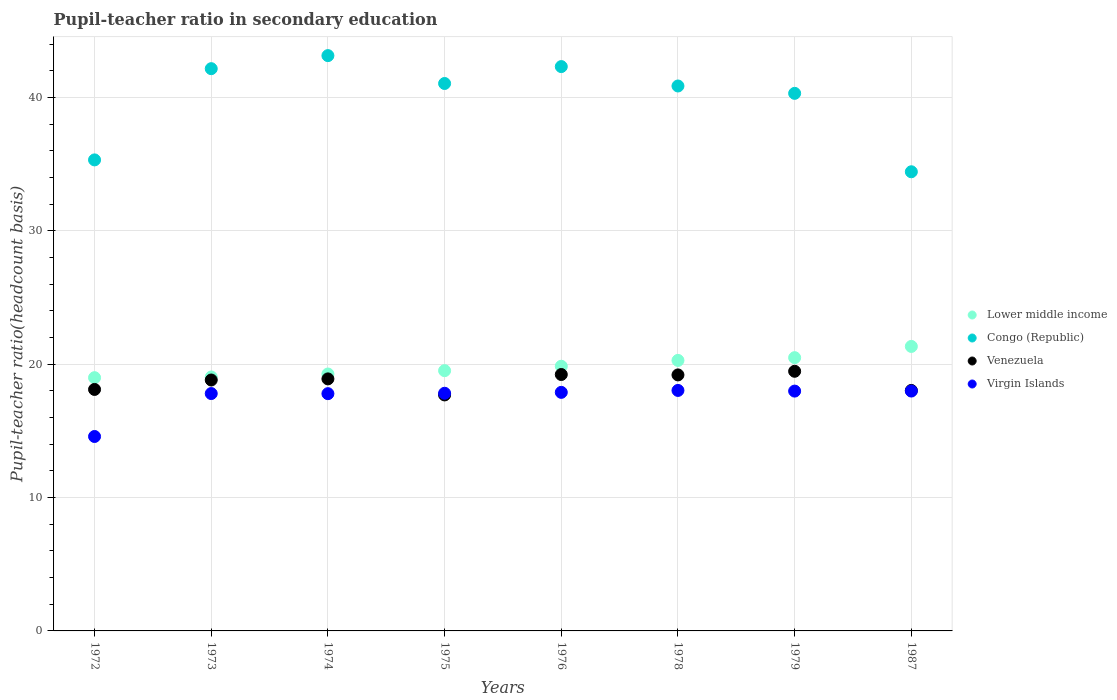How many different coloured dotlines are there?
Make the answer very short. 4. What is the pupil-teacher ratio in secondary education in Congo (Republic) in 1975?
Provide a succinct answer. 41.05. Across all years, what is the maximum pupil-teacher ratio in secondary education in Venezuela?
Your response must be concise. 19.47. Across all years, what is the minimum pupil-teacher ratio in secondary education in Virgin Islands?
Provide a succinct answer. 14.58. In which year was the pupil-teacher ratio in secondary education in Venezuela maximum?
Provide a succinct answer. 1979. What is the total pupil-teacher ratio in secondary education in Congo (Republic) in the graph?
Offer a terse response. 319.59. What is the difference between the pupil-teacher ratio in secondary education in Virgin Islands in 1974 and that in 1976?
Keep it short and to the point. -0.1. What is the difference between the pupil-teacher ratio in secondary education in Lower middle income in 1973 and the pupil-teacher ratio in secondary education in Venezuela in 1976?
Provide a succinct answer. -0.19. What is the average pupil-teacher ratio in secondary education in Lower middle income per year?
Offer a terse response. 19.85. In the year 1975, what is the difference between the pupil-teacher ratio in secondary education in Virgin Islands and pupil-teacher ratio in secondary education in Congo (Republic)?
Offer a very short reply. -23.23. In how many years, is the pupil-teacher ratio in secondary education in Congo (Republic) greater than 28?
Your answer should be compact. 8. What is the ratio of the pupil-teacher ratio in secondary education in Virgin Islands in 1978 to that in 1987?
Ensure brevity in your answer.  1. What is the difference between the highest and the second highest pupil-teacher ratio in secondary education in Venezuela?
Provide a short and direct response. 0.24. What is the difference between the highest and the lowest pupil-teacher ratio in secondary education in Lower middle income?
Ensure brevity in your answer.  2.34. In how many years, is the pupil-teacher ratio in secondary education in Venezuela greater than the average pupil-teacher ratio in secondary education in Venezuela taken over all years?
Your answer should be compact. 5. Is the sum of the pupil-teacher ratio in secondary education in Congo (Republic) in 1976 and 1978 greater than the maximum pupil-teacher ratio in secondary education in Virgin Islands across all years?
Offer a terse response. Yes. Is it the case that in every year, the sum of the pupil-teacher ratio in secondary education in Venezuela and pupil-teacher ratio in secondary education in Virgin Islands  is greater than the sum of pupil-teacher ratio in secondary education in Congo (Republic) and pupil-teacher ratio in secondary education in Lower middle income?
Offer a very short reply. No. Is it the case that in every year, the sum of the pupil-teacher ratio in secondary education in Venezuela and pupil-teacher ratio in secondary education in Lower middle income  is greater than the pupil-teacher ratio in secondary education in Virgin Islands?
Your answer should be very brief. Yes. Does the pupil-teacher ratio in secondary education in Lower middle income monotonically increase over the years?
Make the answer very short. Yes. How many years are there in the graph?
Give a very brief answer. 8. What is the difference between two consecutive major ticks on the Y-axis?
Offer a terse response. 10. Are the values on the major ticks of Y-axis written in scientific E-notation?
Provide a succinct answer. No. Does the graph contain any zero values?
Your answer should be very brief. No. How many legend labels are there?
Offer a terse response. 4. What is the title of the graph?
Offer a terse response. Pupil-teacher ratio in secondary education. Does "Faeroe Islands" appear as one of the legend labels in the graph?
Keep it short and to the point. No. What is the label or title of the Y-axis?
Make the answer very short. Pupil-teacher ratio(headcount basis). What is the Pupil-teacher ratio(headcount basis) in Lower middle income in 1972?
Ensure brevity in your answer.  18.99. What is the Pupil-teacher ratio(headcount basis) in Congo (Republic) in 1972?
Give a very brief answer. 35.32. What is the Pupil-teacher ratio(headcount basis) of Venezuela in 1972?
Provide a succinct answer. 18.11. What is the Pupil-teacher ratio(headcount basis) of Virgin Islands in 1972?
Offer a terse response. 14.58. What is the Pupil-teacher ratio(headcount basis) of Lower middle income in 1973?
Your answer should be very brief. 19.04. What is the Pupil-teacher ratio(headcount basis) in Congo (Republic) in 1973?
Offer a very short reply. 42.16. What is the Pupil-teacher ratio(headcount basis) in Venezuela in 1973?
Offer a terse response. 18.82. What is the Pupil-teacher ratio(headcount basis) of Virgin Islands in 1973?
Your answer should be compact. 17.8. What is the Pupil-teacher ratio(headcount basis) in Lower middle income in 1974?
Your answer should be compact. 19.26. What is the Pupil-teacher ratio(headcount basis) of Congo (Republic) in 1974?
Your response must be concise. 43.14. What is the Pupil-teacher ratio(headcount basis) of Venezuela in 1974?
Make the answer very short. 18.9. What is the Pupil-teacher ratio(headcount basis) in Virgin Islands in 1974?
Make the answer very short. 17.79. What is the Pupil-teacher ratio(headcount basis) of Lower middle income in 1975?
Provide a succinct answer. 19.52. What is the Pupil-teacher ratio(headcount basis) of Congo (Republic) in 1975?
Your answer should be very brief. 41.05. What is the Pupil-teacher ratio(headcount basis) in Venezuela in 1975?
Provide a short and direct response. 17.7. What is the Pupil-teacher ratio(headcount basis) of Virgin Islands in 1975?
Provide a short and direct response. 17.82. What is the Pupil-teacher ratio(headcount basis) of Lower middle income in 1976?
Provide a short and direct response. 19.85. What is the Pupil-teacher ratio(headcount basis) in Congo (Republic) in 1976?
Offer a very short reply. 42.32. What is the Pupil-teacher ratio(headcount basis) in Venezuela in 1976?
Keep it short and to the point. 19.23. What is the Pupil-teacher ratio(headcount basis) of Virgin Islands in 1976?
Your response must be concise. 17.89. What is the Pupil-teacher ratio(headcount basis) in Lower middle income in 1978?
Offer a very short reply. 20.28. What is the Pupil-teacher ratio(headcount basis) of Congo (Republic) in 1978?
Keep it short and to the point. 40.86. What is the Pupil-teacher ratio(headcount basis) of Venezuela in 1978?
Your answer should be compact. 19.2. What is the Pupil-teacher ratio(headcount basis) in Virgin Islands in 1978?
Your response must be concise. 18.03. What is the Pupil-teacher ratio(headcount basis) in Lower middle income in 1979?
Your answer should be compact. 20.49. What is the Pupil-teacher ratio(headcount basis) in Congo (Republic) in 1979?
Give a very brief answer. 40.31. What is the Pupil-teacher ratio(headcount basis) of Venezuela in 1979?
Your answer should be compact. 19.47. What is the Pupil-teacher ratio(headcount basis) in Virgin Islands in 1979?
Offer a very short reply. 17.98. What is the Pupil-teacher ratio(headcount basis) of Lower middle income in 1987?
Offer a terse response. 21.33. What is the Pupil-teacher ratio(headcount basis) of Congo (Republic) in 1987?
Provide a succinct answer. 34.43. What is the Pupil-teacher ratio(headcount basis) of Venezuela in 1987?
Offer a terse response. 18.03. What is the Pupil-teacher ratio(headcount basis) of Virgin Islands in 1987?
Provide a succinct answer. 17.99. Across all years, what is the maximum Pupil-teacher ratio(headcount basis) in Lower middle income?
Make the answer very short. 21.33. Across all years, what is the maximum Pupil-teacher ratio(headcount basis) in Congo (Republic)?
Keep it short and to the point. 43.14. Across all years, what is the maximum Pupil-teacher ratio(headcount basis) in Venezuela?
Offer a terse response. 19.47. Across all years, what is the maximum Pupil-teacher ratio(headcount basis) in Virgin Islands?
Make the answer very short. 18.03. Across all years, what is the minimum Pupil-teacher ratio(headcount basis) in Lower middle income?
Keep it short and to the point. 18.99. Across all years, what is the minimum Pupil-teacher ratio(headcount basis) in Congo (Republic)?
Keep it short and to the point. 34.43. Across all years, what is the minimum Pupil-teacher ratio(headcount basis) in Venezuela?
Make the answer very short. 17.7. Across all years, what is the minimum Pupil-teacher ratio(headcount basis) of Virgin Islands?
Keep it short and to the point. 14.58. What is the total Pupil-teacher ratio(headcount basis) of Lower middle income in the graph?
Offer a terse response. 158.76. What is the total Pupil-teacher ratio(headcount basis) of Congo (Republic) in the graph?
Give a very brief answer. 319.59. What is the total Pupil-teacher ratio(headcount basis) of Venezuela in the graph?
Offer a terse response. 149.44. What is the total Pupil-teacher ratio(headcount basis) in Virgin Islands in the graph?
Provide a short and direct response. 139.88. What is the difference between the Pupil-teacher ratio(headcount basis) in Lower middle income in 1972 and that in 1973?
Your answer should be very brief. -0.05. What is the difference between the Pupil-teacher ratio(headcount basis) of Congo (Republic) in 1972 and that in 1973?
Your answer should be very brief. -6.84. What is the difference between the Pupil-teacher ratio(headcount basis) in Venezuela in 1972 and that in 1973?
Ensure brevity in your answer.  -0.71. What is the difference between the Pupil-teacher ratio(headcount basis) of Virgin Islands in 1972 and that in 1973?
Your answer should be very brief. -3.22. What is the difference between the Pupil-teacher ratio(headcount basis) of Lower middle income in 1972 and that in 1974?
Offer a very short reply. -0.27. What is the difference between the Pupil-teacher ratio(headcount basis) in Congo (Republic) in 1972 and that in 1974?
Offer a very short reply. -7.82. What is the difference between the Pupil-teacher ratio(headcount basis) of Venezuela in 1972 and that in 1974?
Your response must be concise. -0.79. What is the difference between the Pupil-teacher ratio(headcount basis) of Virgin Islands in 1972 and that in 1974?
Offer a very short reply. -3.21. What is the difference between the Pupil-teacher ratio(headcount basis) of Lower middle income in 1972 and that in 1975?
Offer a terse response. -0.53. What is the difference between the Pupil-teacher ratio(headcount basis) of Congo (Republic) in 1972 and that in 1975?
Your answer should be very brief. -5.73. What is the difference between the Pupil-teacher ratio(headcount basis) in Venezuela in 1972 and that in 1975?
Your answer should be very brief. 0.41. What is the difference between the Pupil-teacher ratio(headcount basis) of Virgin Islands in 1972 and that in 1975?
Your answer should be very brief. -3.24. What is the difference between the Pupil-teacher ratio(headcount basis) of Lower middle income in 1972 and that in 1976?
Give a very brief answer. -0.86. What is the difference between the Pupil-teacher ratio(headcount basis) of Congo (Republic) in 1972 and that in 1976?
Your answer should be compact. -7. What is the difference between the Pupil-teacher ratio(headcount basis) in Venezuela in 1972 and that in 1976?
Your answer should be very brief. -1.12. What is the difference between the Pupil-teacher ratio(headcount basis) of Virgin Islands in 1972 and that in 1976?
Your response must be concise. -3.31. What is the difference between the Pupil-teacher ratio(headcount basis) of Lower middle income in 1972 and that in 1978?
Provide a short and direct response. -1.29. What is the difference between the Pupil-teacher ratio(headcount basis) in Congo (Republic) in 1972 and that in 1978?
Make the answer very short. -5.54. What is the difference between the Pupil-teacher ratio(headcount basis) of Venezuela in 1972 and that in 1978?
Your response must be concise. -1.09. What is the difference between the Pupil-teacher ratio(headcount basis) of Virgin Islands in 1972 and that in 1978?
Your answer should be compact. -3.45. What is the difference between the Pupil-teacher ratio(headcount basis) of Lower middle income in 1972 and that in 1979?
Your answer should be very brief. -1.5. What is the difference between the Pupil-teacher ratio(headcount basis) in Congo (Republic) in 1972 and that in 1979?
Your answer should be compact. -4.99. What is the difference between the Pupil-teacher ratio(headcount basis) in Venezuela in 1972 and that in 1979?
Keep it short and to the point. -1.36. What is the difference between the Pupil-teacher ratio(headcount basis) of Virgin Islands in 1972 and that in 1979?
Keep it short and to the point. -3.4. What is the difference between the Pupil-teacher ratio(headcount basis) in Lower middle income in 1972 and that in 1987?
Make the answer very short. -2.34. What is the difference between the Pupil-teacher ratio(headcount basis) of Congo (Republic) in 1972 and that in 1987?
Offer a terse response. 0.89. What is the difference between the Pupil-teacher ratio(headcount basis) of Venezuela in 1972 and that in 1987?
Offer a very short reply. 0.07. What is the difference between the Pupil-teacher ratio(headcount basis) in Virgin Islands in 1972 and that in 1987?
Make the answer very short. -3.41. What is the difference between the Pupil-teacher ratio(headcount basis) of Lower middle income in 1973 and that in 1974?
Offer a terse response. -0.22. What is the difference between the Pupil-teacher ratio(headcount basis) in Congo (Republic) in 1973 and that in 1974?
Offer a terse response. -0.98. What is the difference between the Pupil-teacher ratio(headcount basis) of Venezuela in 1973 and that in 1974?
Your answer should be very brief. -0.08. What is the difference between the Pupil-teacher ratio(headcount basis) in Virgin Islands in 1973 and that in 1974?
Your answer should be very brief. 0.01. What is the difference between the Pupil-teacher ratio(headcount basis) of Lower middle income in 1973 and that in 1975?
Your answer should be very brief. -0.47. What is the difference between the Pupil-teacher ratio(headcount basis) in Congo (Republic) in 1973 and that in 1975?
Your answer should be very brief. 1.11. What is the difference between the Pupil-teacher ratio(headcount basis) in Venezuela in 1973 and that in 1975?
Offer a very short reply. 1.12. What is the difference between the Pupil-teacher ratio(headcount basis) in Virgin Islands in 1973 and that in 1975?
Make the answer very short. -0.02. What is the difference between the Pupil-teacher ratio(headcount basis) of Lower middle income in 1973 and that in 1976?
Make the answer very short. -0.81. What is the difference between the Pupil-teacher ratio(headcount basis) in Congo (Republic) in 1973 and that in 1976?
Offer a terse response. -0.16. What is the difference between the Pupil-teacher ratio(headcount basis) in Venezuela in 1973 and that in 1976?
Keep it short and to the point. -0.41. What is the difference between the Pupil-teacher ratio(headcount basis) in Virgin Islands in 1973 and that in 1976?
Provide a short and direct response. -0.09. What is the difference between the Pupil-teacher ratio(headcount basis) of Lower middle income in 1973 and that in 1978?
Your response must be concise. -1.24. What is the difference between the Pupil-teacher ratio(headcount basis) in Congo (Republic) in 1973 and that in 1978?
Keep it short and to the point. 1.3. What is the difference between the Pupil-teacher ratio(headcount basis) of Venezuela in 1973 and that in 1978?
Provide a succinct answer. -0.38. What is the difference between the Pupil-teacher ratio(headcount basis) of Virgin Islands in 1973 and that in 1978?
Ensure brevity in your answer.  -0.23. What is the difference between the Pupil-teacher ratio(headcount basis) in Lower middle income in 1973 and that in 1979?
Your answer should be compact. -1.45. What is the difference between the Pupil-teacher ratio(headcount basis) in Congo (Republic) in 1973 and that in 1979?
Your answer should be very brief. 1.85. What is the difference between the Pupil-teacher ratio(headcount basis) in Venezuela in 1973 and that in 1979?
Your answer should be compact. -0.65. What is the difference between the Pupil-teacher ratio(headcount basis) in Virgin Islands in 1973 and that in 1979?
Provide a short and direct response. -0.18. What is the difference between the Pupil-teacher ratio(headcount basis) of Lower middle income in 1973 and that in 1987?
Give a very brief answer. -2.29. What is the difference between the Pupil-teacher ratio(headcount basis) of Congo (Republic) in 1973 and that in 1987?
Ensure brevity in your answer.  7.73. What is the difference between the Pupil-teacher ratio(headcount basis) in Venezuela in 1973 and that in 1987?
Keep it short and to the point. 0.78. What is the difference between the Pupil-teacher ratio(headcount basis) in Virgin Islands in 1973 and that in 1987?
Keep it short and to the point. -0.19. What is the difference between the Pupil-teacher ratio(headcount basis) in Lower middle income in 1974 and that in 1975?
Ensure brevity in your answer.  -0.25. What is the difference between the Pupil-teacher ratio(headcount basis) of Congo (Republic) in 1974 and that in 1975?
Provide a succinct answer. 2.09. What is the difference between the Pupil-teacher ratio(headcount basis) of Venezuela in 1974 and that in 1975?
Ensure brevity in your answer.  1.2. What is the difference between the Pupil-teacher ratio(headcount basis) of Virgin Islands in 1974 and that in 1975?
Make the answer very short. -0.03. What is the difference between the Pupil-teacher ratio(headcount basis) of Lower middle income in 1974 and that in 1976?
Provide a short and direct response. -0.58. What is the difference between the Pupil-teacher ratio(headcount basis) of Congo (Republic) in 1974 and that in 1976?
Give a very brief answer. 0.82. What is the difference between the Pupil-teacher ratio(headcount basis) of Venezuela in 1974 and that in 1976?
Your answer should be compact. -0.33. What is the difference between the Pupil-teacher ratio(headcount basis) of Virgin Islands in 1974 and that in 1976?
Keep it short and to the point. -0.1. What is the difference between the Pupil-teacher ratio(headcount basis) of Lower middle income in 1974 and that in 1978?
Provide a short and direct response. -1.02. What is the difference between the Pupil-teacher ratio(headcount basis) in Congo (Republic) in 1974 and that in 1978?
Offer a terse response. 2.28. What is the difference between the Pupil-teacher ratio(headcount basis) in Venezuela in 1974 and that in 1978?
Give a very brief answer. -0.3. What is the difference between the Pupil-teacher ratio(headcount basis) of Virgin Islands in 1974 and that in 1978?
Provide a short and direct response. -0.24. What is the difference between the Pupil-teacher ratio(headcount basis) of Lower middle income in 1974 and that in 1979?
Provide a succinct answer. -1.23. What is the difference between the Pupil-teacher ratio(headcount basis) in Congo (Republic) in 1974 and that in 1979?
Provide a succinct answer. 2.83. What is the difference between the Pupil-teacher ratio(headcount basis) of Venezuela in 1974 and that in 1979?
Offer a very short reply. -0.57. What is the difference between the Pupil-teacher ratio(headcount basis) of Virgin Islands in 1974 and that in 1979?
Ensure brevity in your answer.  -0.19. What is the difference between the Pupil-teacher ratio(headcount basis) in Lower middle income in 1974 and that in 1987?
Your answer should be compact. -2.07. What is the difference between the Pupil-teacher ratio(headcount basis) in Congo (Republic) in 1974 and that in 1987?
Your answer should be very brief. 8.71. What is the difference between the Pupil-teacher ratio(headcount basis) of Venezuela in 1974 and that in 1987?
Keep it short and to the point. 0.87. What is the difference between the Pupil-teacher ratio(headcount basis) of Virgin Islands in 1974 and that in 1987?
Your answer should be compact. -0.2. What is the difference between the Pupil-teacher ratio(headcount basis) in Lower middle income in 1975 and that in 1976?
Ensure brevity in your answer.  -0.33. What is the difference between the Pupil-teacher ratio(headcount basis) in Congo (Republic) in 1975 and that in 1976?
Provide a succinct answer. -1.27. What is the difference between the Pupil-teacher ratio(headcount basis) of Venezuela in 1975 and that in 1976?
Keep it short and to the point. -1.53. What is the difference between the Pupil-teacher ratio(headcount basis) in Virgin Islands in 1975 and that in 1976?
Keep it short and to the point. -0.07. What is the difference between the Pupil-teacher ratio(headcount basis) of Lower middle income in 1975 and that in 1978?
Offer a terse response. -0.77. What is the difference between the Pupil-teacher ratio(headcount basis) of Congo (Republic) in 1975 and that in 1978?
Provide a succinct answer. 0.19. What is the difference between the Pupil-teacher ratio(headcount basis) of Venezuela in 1975 and that in 1978?
Your answer should be compact. -1.5. What is the difference between the Pupil-teacher ratio(headcount basis) in Virgin Islands in 1975 and that in 1978?
Make the answer very short. -0.21. What is the difference between the Pupil-teacher ratio(headcount basis) in Lower middle income in 1975 and that in 1979?
Provide a short and direct response. -0.97. What is the difference between the Pupil-teacher ratio(headcount basis) in Congo (Republic) in 1975 and that in 1979?
Your answer should be compact. 0.74. What is the difference between the Pupil-teacher ratio(headcount basis) in Venezuela in 1975 and that in 1979?
Offer a terse response. -1.77. What is the difference between the Pupil-teacher ratio(headcount basis) of Virgin Islands in 1975 and that in 1979?
Keep it short and to the point. -0.16. What is the difference between the Pupil-teacher ratio(headcount basis) in Lower middle income in 1975 and that in 1987?
Ensure brevity in your answer.  -1.82. What is the difference between the Pupil-teacher ratio(headcount basis) in Congo (Republic) in 1975 and that in 1987?
Provide a succinct answer. 6.62. What is the difference between the Pupil-teacher ratio(headcount basis) of Venezuela in 1975 and that in 1987?
Provide a succinct answer. -0.34. What is the difference between the Pupil-teacher ratio(headcount basis) of Virgin Islands in 1975 and that in 1987?
Your answer should be very brief. -0.17. What is the difference between the Pupil-teacher ratio(headcount basis) in Lower middle income in 1976 and that in 1978?
Your answer should be compact. -0.44. What is the difference between the Pupil-teacher ratio(headcount basis) in Congo (Republic) in 1976 and that in 1978?
Provide a succinct answer. 1.45. What is the difference between the Pupil-teacher ratio(headcount basis) of Venezuela in 1976 and that in 1978?
Give a very brief answer. 0.03. What is the difference between the Pupil-teacher ratio(headcount basis) in Virgin Islands in 1976 and that in 1978?
Keep it short and to the point. -0.14. What is the difference between the Pupil-teacher ratio(headcount basis) in Lower middle income in 1976 and that in 1979?
Give a very brief answer. -0.64. What is the difference between the Pupil-teacher ratio(headcount basis) in Congo (Republic) in 1976 and that in 1979?
Make the answer very short. 2.01. What is the difference between the Pupil-teacher ratio(headcount basis) in Venezuela in 1976 and that in 1979?
Offer a very short reply. -0.24. What is the difference between the Pupil-teacher ratio(headcount basis) of Virgin Islands in 1976 and that in 1979?
Provide a short and direct response. -0.09. What is the difference between the Pupil-teacher ratio(headcount basis) in Lower middle income in 1976 and that in 1987?
Provide a short and direct response. -1.49. What is the difference between the Pupil-teacher ratio(headcount basis) in Congo (Republic) in 1976 and that in 1987?
Offer a terse response. 7.89. What is the difference between the Pupil-teacher ratio(headcount basis) of Venezuela in 1976 and that in 1987?
Make the answer very short. 1.19. What is the difference between the Pupil-teacher ratio(headcount basis) in Virgin Islands in 1976 and that in 1987?
Keep it short and to the point. -0.1. What is the difference between the Pupil-teacher ratio(headcount basis) of Lower middle income in 1978 and that in 1979?
Make the answer very short. -0.21. What is the difference between the Pupil-teacher ratio(headcount basis) in Congo (Republic) in 1978 and that in 1979?
Offer a very short reply. 0.55. What is the difference between the Pupil-teacher ratio(headcount basis) of Venezuela in 1978 and that in 1979?
Your response must be concise. -0.27. What is the difference between the Pupil-teacher ratio(headcount basis) of Virgin Islands in 1978 and that in 1979?
Your answer should be very brief. 0.05. What is the difference between the Pupil-teacher ratio(headcount basis) of Lower middle income in 1978 and that in 1987?
Give a very brief answer. -1.05. What is the difference between the Pupil-teacher ratio(headcount basis) in Congo (Republic) in 1978 and that in 1987?
Your answer should be compact. 6.43. What is the difference between the Pupil-teacher ratio(headcount basis) of Venezuela in 1978 and that in 1987?
Your answer should be very brief. 1.16. What is the difference between the Pupil-teacher ratio(headcount basis) of Virgin Islands in 1978 and that in 1987?
Provide a succinct answer. 0.05. What is the difference between the Pupil-teacher ratio(headcount basis) in Lower middle income in 1979 and that in 1987?
Offer a very short reply. -0.84. What is the difference between the Pupil-teacher ratio(headcount basis) of Congo (Republic) in 1979 and that in 1987?
Offer a terse response. 5.88. What is the difference between the Pupil-teacher ratio(headcount basis) in Venezuela in 1979 and that in 1987?
Your answer should be very brief. 1.44. What is the difference between the Pupil-teacher ratio(headcount basis) in Virgin Islands in 1979 and that in 1987?
Give a very brief answer. -0. What is the difference between the Pupil-teacher ratio(headcount basis) in Lower middle income in 1972 and the Pupil-teacher ratio(headcount basis) in Congo (Republic) in 1973?
Offer a terse response. -23.17. What is the difference between the Pupil-teacher ratio(headcount basis) in Lower middle income in 1972 and the Pupil-teacher ratio(headcount basis) in Venezuela in 1973?
Keep it short and to the point. 0.17. What is the difference between the Pupil-teacher ratio(headcount basis) in Lower middle income in 1972 and the Pupil-teacher ratio(headcount basis) in Virgin Islands in 1973?
Your answer should be compact. 1.19. What is the difference between the Pupil-teacher ratio(headcount basis) in Congo (Republic) in 1972 and the Pupil-teacher ratio(headcount basis) in Venezuela in 1973?
Your answer should be compact. 16.5. What is the difference between the Pupil-teacher ratio(headcount basis) in Congo (Republic) in 1972 and the Pupil-teacher ratio(headcount basis) in Virgin Islands in 1973?
Offer a terse response. 17.52. What is the difference between the Pupil-teacher ratio(headcount basis) in Venezuela in 1972 and the Pupil-teacher ratio(headcount basis) in Virgin Islands in 1973?
Keep it short and to the point. 0.31. What is the difference between the Pupil-teacher ratio(headcount basis) in Lower middle income in 1972 and the Pupil-teacher ratio(headcount basis) in Congo (Republic) in 1974?
Give a very brief answer. -24.15. What is the difference between the Pupil-teacher ratio(headcount basis) in Lower middle income in 1972 and the Pupil-teacher ratio(headcount basis) in Venezuela in 1974?
Ensure brevity in your answer.  0.09. What is the difference between the Pupil-teacher ratio(headcount basis) of Lower middle income in 1972 and the Pupil-teacher ratio(headcount basis) of Virgin Islands in 1974?
Give a very brief answer. 1.2. What is the difference between the Pupil-teacher ratio(headcount basis) of Congo (Republic) in 1972 and the Pupil-teacher ratio(headcount basis) of Venezuela in 1974?
Your answer should be compact. 16.42. What is the difference between the Pupil-teacher ratio(headcount basis) in Congo (Republic) in 1972 and the Pupil-teacher ratio(headcount basis) in Virgin Islands in 1974?
Make the answer very short. 17.53. What is the difference between the Pupil-teacher ratio(headcount basis) in Venezuela in 1972 and the Pupil-teacher ratio(headcount basis) in Virgin Islands in 1974?
Your answer should be compact. 0.32. What is the difference between the Pupil-teacher ratio(headcount basis) of Lower middle income in 1972 and the Pupil-teacher ratio(headcount basis) of Congo (Republic) in 1975?
Ensure brevity in your answer.  -22.06. What is the difference between the Pupil-teacher ratio(headcount basis) of Lower middle income in 1972 and the Pupil-teacher ratio(headcount basis) of Venezuela in 1975?
Make the answer very short. 1.29. What is the difference between the Pupil-teacher ratio(headcount basis) in Lower middle income in 1972 and the Pupil-teacher ratio(headcount basis) in Virgin Islands in 1975?
Offer a very short reply. 1.17. What is the difference between the Pupil-teacher ratio(headcount basis) of Congo (Republic) in 1972 and the Pupil-teacher ratio(headcount basis) of Venezuela in 1975?
Keep it short and to the point. 17.62. What is the difference between the Pupil-teacher ratio(headcount basis) of Congo (Republic) in 1972 and the Pupil-teacher ratio(headcount basis) of Virgin Islands in 1975?
Give a very brief answer. 17.5. What is the difference between the Pupil-teacher ratio(headcount basis) of Venezuela in 1972 and the Pupil-teacher ratio(headcount basis) of Virgin Islands in 1975?
Offer a very short reply. 0.29. What is the difference between the Pupil-teacher ratio(headcount basis) in Lower middle income in 1972 and the Pupil-teacher ratio(headcount basis) in Congo (Republic) in 1976?
Offer a very short reply. -23.33. What is the difference between the Pupil-teacher ratio(headcount basis) of Lower middle income in 1972 and the Pupil-teacher ratio(headcount basis) of Venezuela in 1976?
Offer a terse response. -0.24. What is the difference between the Pupil-teacher ratio(headcount basis) in Lower middle income in 1972 and the Pupil-teacher ratio(headcount basis) in Virgin Islands in 1976?
Your response must be concise. 1.1. What is the difference between the Pupil-teacher ratio(headcount basis) in Congo (Republic) in 1972 and the Pupil-teacher ratio(headcount basis) in Venezuela in 1976?
Keep it short and to the point. 16.09. What is the difference between the Pupil-teacher ratio(headcount basis) in Congo (Republic) in 1972 and the Pupil-teacher ratio(headcount basis) in Virgin Islands in 1976?
Give a very brief answer. 17.43. What is the difference between the Pupil-teacher ratio(headcount basis) of Venezuela in 1972 and the Pupil-teacher ratio(headcount basis) of Virgin Islands in 1976?
Offer a very short reply. 0.22. What is the difference between the Pupil-teacher ratio(headcount basis) of Lower middle income in 1972 and the Pupil-teacher ratio(headcount basis) of Congo (Republic) in 1978?
Provide a succinct answer. -21.87. What is the difference between the Pupil-teacher ratio(headcount basis) of Lower middle income in 1972 and the Pupil-teacher ratio(headcount basis) of Venezuela in 1978?
Offer a terse response. -0.21. What is the difference between the Pupil-teacher ratio(headcount basis) of Lower middle income in 1972 and the Pupil-teacher ratio(headcount basis) of Virgin Islands in 1978?
Your answer should be very brief. 0.96. What is the difference between the Pupil-teacher ratio(headcount basis) of Congo (Republic) in 1972 and the Pupil-teacher ratio(headcount basis) of Venezuela in 1978?
Keep it short and to the point. 16.12. What is the difference between the Pupil-teacher ratio(headcount basis) of Congo (Republic) in 1972 and the Pupil-teacher ratio(headcount basis) of Virgin Islands in 1978?
Give a very brief answer. 17.29. What is the difference between the Pupil-teacher ratio(headcount basis) of Venezuela in 1972 and the Pupil-teacher ratio(headcount basis) of Virgin Islands in 1978?
Your answer should be very brief. 0.07. What is the difference between the Pupil-teacher ratio(headcount basis) in Lower middle income in 1972 and the Pupil-teacher ratio(headcount basis) in Congo (Republic) in 1979?
Offer a terse response. -21.32. What is the difference between the Pupil-teacher ratio(headcount basis) of Lower middle income in 1972 and the Pupil-teacher ratio(headcount basis) of Venezuela in 1979?
Keep it short and to the point. -0.48. What is the difference between the Pupil-teacher ratio(headcount basis) in Congo (Republic) in 1972 and the Pupil-teacher ratio(headcount basis) in Venezuela in 1979?
Your answer should be very brief. 15.85. What is the difference between the Pupil-teacher ratio(headcount basis) of Congo (Republic) in 1972 and the Pupil-teacher ratio(headcount basis) of Virgin Islands in 1979?
Your answer should be compact. 17.34. What is the difference between the Pupil-teacher ratio(headcount basis) in Venezuela in 1972 and the Pupil-teacher ratio(headcount basis) in Virgin Islands in 1979?
Provide a short and direct response. 0.12. What is the difference between the Pupil-teacher ratio(headcount basis) of Lower middle income in 1972 and the Pupil-teacher ratio(headcount basis) of Congo (Republic) in 1987?
Your answer should be very brief. -15.44. What is the difference between the Pupil-teacher ratio(headcount basis) in Lower middle income in 1972 and the Pupil-teacher ratio(headcount basis) in Venezuela in 1987?
Keep it short and to the point. 0.96. What is the difference between the Pupil-teacher ratio(headcount basis) in Congo (Republic) in 1972 and the Pupil-teacher ratio(headcount basis) in Venezuela in 1987?
Provide a succinct answer. 17.29. What is the difference between the Pupil-teacher ratio(headcount basis) in Congo (Republic) in 1972 and the Pupil-teacher ratio(headcount basis) in Virgin Islands in 1987?
Offer a very short reply. 17.33. What is the difference between the Pupil-teacher ratio(headcount basis) of Venezuela in 1972 and the Pupil-teacher ratio(headcount basis) of Virgin Islands in 1987?
Your answer should be compact. 0.12. What is the difference between the Pupil-teacher ratio(headcount basis) of Lower middle income in 1973 and the Pupil-teacher ratio(headcount basis) of Congo (Republic) in 1974?
Provide a succinct answer. -24.1. What is the difference between the Pupil-teacher ratio(headcount basis) in Lower middle income in 1973 and the Pupil-teacher ratio(headcount basis) in Venezuela in 1974?
Offer a terse response. 0.14. What is the difference between the Pupil-teacher ratio(headcount basis) in Lower middle income in 1973 and the Pupil-teacher ratio(headcount basis) in Virgin Islands in 1974?
Offer a very short reply. 1.25. What is the difference between the Pupil-teacher ratio(headcount basis) of Congo (Republic) in 1973 and the Pupil-teacher ratio(headcount basis) of Venezuela in 1974?
Your response must be concise. 23.26. What is the difference between the Pupil-teacher ratio(headcount basis) of Congo (Republic) in 1973 and the Pupil-teacher ratio(headcount basis) of Virgin Islands in 1974?
Provide a succinct answer. 24.37. What is the difference between the Pupil-teacher ratio(headcount basis) of Venezuela in 1973 and the Pupil-teacher ratio(headcount basis) of Virgin Islands in 1974?
Make the answer very short. 1.02. What is the difference between the Pupil-teacher ratio(headcount basis) of Lower middle income in 1973 and the Pupil-teacher ratio(headcount basis) of Congo (Republic) in 1975?
Make the answer very short. -22.01. What is the difference between the Pupil-teacher ratio(headcount basis) of Lower middle income in 1973 and the Pupil-teacher ratio(headcount basis) of Venezuela in 1975?
Offer a terse response. 1.35. What is the difference between the Pupil-teacher ratio(headcount basis) of Lower middle income in 1973 and the Pupil-teacher ratio(headcount basis) of Virgin Islands in 1975?
Provide a succinct answer. 1.22. What is the difference between the Pupil-teacher ratio(headcount basis) of Congo (Republic) in 1973 and the Pupil-teacher ratio(headcount basis) of Venezuela in 1975?
Make the answer very short. 24.47. What is the difference between the Pupil-teacher ratio(headcount basis) of Congo (Republic) in 1973 and the Pupil-teacher ratio(headcount basis) of Virgin Islands in 1975?
Keep it short and to the point. 24.34. What is the difference between the Pupil-teacher ratio(headcount basis) of Venezuela in 1973 and the Pupil-teacher ratio(headcount basis) of Virgin Islands in 1975?
Your response must be concise. 0.99. What is the difference between the Pupil-teacher ratio(headcount basis) in Lower middle income in 1973 and the Pupil-teacher ratio(headcount basis) in Congo (Republic) in 1976?
Offer a very short reply. -23.28. What is the difference between the Pupil-teacher ratio(headcount basis) in Lower middle income in 1973 and the Pupil-teacher ratio(headcount basis) in Venezuela in 1976?
Your answer should be compact. -0.19. What is the difference between the Pupil-teacher ratio(headcount basis) in Lower middle income in 1973 and the Pupil-teacher ratio(headcount basis) in Virgin Islands in 1976?
Your response must be concise. 1.15. What is the difference between the Pupil-teacher ratio(headcount basis) in Congo (Republic) in 1973 and the Pupil-teacher ratio(headcount basis) in Venezuela in 1976?
Keep it short and to the point. 22.93. What is the difference between the Pupil-teacher ratio(headcount basis) in Congo (Republic) in 1973 and the Pupil-teacher ratio(headcount basis) in Virgin Islands in 1976?
Your answer should be very brief. 24.27. What is the difference between the Pupil-teacher ratio(headcount basis) of Venezuela in 1973 and the Pupil-teacher ratio(headcount basis) of Virgin Islands in 1976?
Provide a succinct answer. 0.93. What is the difference between the Pupil-teacher ratio(headcount basis) of Lower middle income in 1973 and the Pupil-teacher ratio(headcount basis) of Congo (Republic) in 1978?
Give a very brief answer. -21.82. What is the difference between the Pupil-teacher ratio(headcount basis) of Lower middle income in 1973 and the Pupil-teacher ratio(headcount basis) of Venezuela in 1978?
Offer a very short reply. -0.16. What is the difference between the Pupil-teacher ratio(headcount basis) of Lower middle income in 1973 and the Pupil-teacher ratio(headcount basis) of Virgin Islands in 1978?
Your answer should be compact. 1.01. What is the difference between the Pupil-teacher ratio(headcount basis) in Congo (Republic) in 1973 and the Pupil-teacher ratio(headcount basis) in Venezuela in 1978?
Provide a succinct answer. 22.96. What is the difference between the Pupil-teacher ratio(headcount basis) of Congo (Republic) in 1973 and the Pupil-teacher ratio(headcount basis) of Virgin Islands in 1978?
Your answer should be compact. 24.13. What is the difference between the Pupil-teacher ratio(headcount basis) in Venezuela in 1973 and the Pupil-teacher ratio(headcount basis) in Virgin Islands in 1978?
Make the answer very short. 0.78. What is the difference between the Pupil-teacher ratio(headcount basis) in Lower middle income in 1973 and the Pupil-teacher ratio(headcount basis) in Congo (Republic) in 1979?
Keep it short and to the point. -21.27. What is the difference between the Pupil-teacher ratio(headcount basis) of Lower middle income in 1973 and the Pupil-teacher ratio(headcount basis) of Venezuela in 1979?
Offer a terse response. -0.43. What is the difference between the Pupil-teacher ratio(headcount basis) of Lower middle income in 1973 and the Pupil-teacher ratio(headcount basis) of Virgin Islands in 1979?
Your answer should be very brief. 1.06. What is the difference between the Pupil-teacher ratio(headcount basis) in Congo (Republic) in 1973 and the Pupil-teacher ratio(headcount basis) in Venezuela in 1979?
Keep it short and to the point. 22.69. What is the difference between the Pupil-teacher ratio(headcount basis) of Congo (Republic) in 1973 and the Pupil-teacher ratio(headcount basis) of Virgin Islands in 1979?
Your answer should be very brief. 24.18. What is the difference between the Pupil-teacher ratio(headcount basis) in Venezuela in 1973 and the Pupil-teacher ratio(headcount basis) in Virgin Islands in 1979?
Offer a very short reply. 0.83. What is the difference between the Pupil-teacher ratio(headcount basis) of Lower middle income in 1973 and the Pupil-teacher ratio(headcount basis) of Congo (Republic) in 1987?
Your response must be concise. -15.39. What is the difference between the Pupil-teacher ratio(headcount basis) of Lower middle income in 1973 and the Pupil-teacher ratio(headcount basis) of Virgin Islands in 1987?
Ensure brevity in your answer.  1.05. What is the difference between the Pupil-teacher ratio(headcount basis) in Congo (Republic) in 1973 and the Pupil-teacher ratio(headcount basis) in Venezuela in 1987?
Your answer should be very brief. 24.13. What is the difference between the Pupil-teacher ratio(headcount basis) in Congo (Republic) in 1973 and the Pupil-teacher ratio(headcount basis) in Virgin Islands in 1987?
Your answer should be compact. 24.17. What is the difference between the Pupil-teacher ratio(headcount basis) of Venezuela in 1973 and the Pupil-teacher ratio(headcount basis) of Virgin Islands in 1987?
Provide a short and direct response. 0.83. What is the difference between the Pupil-teacher ratio(headcount basis) in Lower middle income in 1974 and the Pupil-teacher ratio(headcount basis) in Congo (Republic) in 1975?
Give a very brief answer. -21.78. What is the difference between the Pupil-teacher ratio(headcount basis) of Lower middle income in 1974 and the Pupil-teacher ratio(headcount basis) of Venezuela in 1975?
Ensure brevity in your answer.  1.57. What is the difference between the Pupil-teacher ratio(headcount basis) in Lower middle income in 1974 and the Pupil-teacher ratio(headcount basis) in Virgin Islands in 1975?
Keep it short and to the point. 1.44. What is the difference between the Pupil-teacher ratio(headcount basis) of Congo (Republic) in 1974 and the Pupil-teacher ratio(headcount basis) of Venezuela in 1975?
Provide a short and direct response. 25.44. What is the difference between the Pupil-teacher ratio(headcount basis) in Congo (Republic) in 1974 and the Pupil-teacher ratio(headcount basis) in Virgin Islands in 1975?
Provide a succinct answer. 25.32. What is the difference between the Pupil-teacher ratio(headcount basis) of Venezuela in 1974 and the Pupil-teacher ratio(headcount basis) of Virgin Islands in 1975?
Offer a very short reply. 1.08. What is the difference between the Pupil-teacher ratio(headcount basis) of Lower middle income in 1974 and the Pupil-teacher ratio(headcount basis) of Congo (Republic) in 1976?
Keep it short and to the point. -23.05. What is the difference between the Pupil-teacher ratio(headcount basis) of Lower middle income in 1974 and the Pupil-teacher ratio(headcount basis) of Venezuela in 1976?
Your response must be concise. 0.04. What is the difference between the Pupil-teacher ratio(headcount basis) in Lower middle income in 1974 and the Pupil-teacher ratio(headcount basis) in Virgin Islands in 1976?
Your answer should be very brief. 1.38. What is the difference between the Pupil-teacher ratio(headcount basis) in Congo (Republic) in 1974 and the Pupil-teacher ratio(headcount basis) in Venezuela in 1976?
Provide a succinct answer. 23.91. What is the difference between the Pupil-teacher ratio(headcount basis) in Congo (Republic) in 1974 and the Pupil-teacher ratio(headcount basis) in Virgin Islands in 1976?
Your answer should be compact. 25.25. What is the difference between the Pupil-teacher ratio(headcount basis) of Lower middle income in 1974 and the Pupil-teacher ratio(headcount basis) of Congo (Republic) in 1978?
Ensure brevity in your answer.  -21.6. What is the difference between the Pupil-teacher ratio(headcount basis) of Lower middle income in 1974 and the Pupil-teacher ratio(headcount basis) of Venezuela in 1978?
Give a very brief answer. 0.07. What is the difference between the Pupil-teacher ratio(headcount basis) in Lower middle income in 1974 and the Pupil-teacher ratio(headcount basis) in Virgin Islands in 1978?
Offer a very short reply. 1.23. What is the difference between the Pupil-teacher ratio(headcount basis) of Congo (Republic) in 1974 and the Pupil-teacher ratio(headcount basis) of Venezuela in 1978?
Your response must be concise. 23.94. What is the difference between the Pupil-teacher ratio(headcount basis) in Congo (Republic) in 1974 and the Pupil-teacher ratio(headcount basis) in Virgin Islands in 1978?
Give a very brief answer. 25.11. What is the difference between the Pupil-teacher ratio(headcount basis) in Venezuela in 1974 and the Pupil-teacher ratio(headcount basis) in Virgin Islands in 1978?
Offer a terse response. 0.87. What is the difference between the Pupil-teacher ratio(headcount basis) of Lower middle income in 1974 and the Pupil-teacher ratio(headcount basis) of Congo (Republic) in 1979?
Provide a short and direct response. -21.04. What is the difference between the Pupil-teacher ratio(headcount basis) of Lower middle income in 1974 and the Pupil-teacher ratio(headcount basis) of Venezuela in 1979?
Provide a short and direct response. -0.2. What is the difference between the Pupil-teacher ratio(headcount basis) in Lower middle income in 1974 and the Pupil-teacher ratio(headcount basis) in Virgin Islands in 1979?
Offer a terse response. 1.28. What is the difference between the Pupil-teacher ratio(headcount basis) in Congo (Republic) in 1974 and the Pupil-teacher ratio(headcount basis) in Venezuela in 1979?
Your response must be concise. 23.67. What is the difference between the Pupil-teacher ratio(headcount basis) of Congo (Republic) in 1974 and the Pupil-teacher ratio(headcount basis) of Virgin Islands in 1979?
Your answer should be very brief. 25.16. What is the difference between the Pupil-teacher ratio(headcount basis) of Venezuela in 1974 and the Pupil-teacher ratio(headcount basis) of Virgin Islands in 1979?
Provide a succinct answer. 0.92. What is the difference between the Pupil-teacher ratio(headcount basis) of Lower middle income in 1974 and the Pupil-teacher ratio(headcount basis) of Congo (Republic) in 1987?
Keep it short and to the point. -15.16. What is the difference between the Pupil-teacher ratio(headcount basis) of Lower middle income in 1974 and the Pupil-teacher ratio(headcount basis) of Venezuela in 1987?
Your answer should be very brief. 1.23. What is the difference between the Pupil-teacher ratio(headcount basis) of Lower middle income in 1974 and the Pupil-teacher ratio(headcount basis) of Virgin Islands in 1987?
Your answer should be compact. 1.28. What is the difference between the Pupil-teacher ratio(headcount basis) of Congo (Republic) in 1974 and the Pupil-teacher ratio(headcount basis) of Venezuela in 1987?
Ensure brevity in your answer.  25.11. What is the difference between the Pupil-teacher ratio(headcount basis) in Congo (Republic) in 1974 and the Pupil-teacher ratio(headcount basis) in Virgin Islands in 1987?
Make the answer very short. 25.15. What is the difference between the Pupil-teacher ratio(headcount basis) in Venezuela in 1974 and the Pupil-teacher ratio(headcount basis) in Virgin Islands in 1987?
Make the answer very short. 0.91. What is the difference between the Pupil-teacher ratio(headcount basis) in Lower middle income in 1975 and the Pupil-teacher ratio(headcount basis) in Congo (Republic) in 1976?
Offer a very short reply. -22.8. What is the difference between the Pupil-teacher ratio(headcount basis) of Lower middle income in 1975 and the Pupil-teacher ratio(headcount basis) of Venezuela in 1976?
Provide a succinct answer. 0.29. What is the difference between the Pupil-teacher ratio(headcount basis) in Lower middle income in 1975 and the Pupil-teacher ratio(headcount basis) in Virgin Islands in 1976?
Make the answer very short. 1.63. What is the difference between the Pupil-teacher ratio(headcount basis) of Congo (Republic) in 1975 and the Pupil-teacher ratio(headcount basis) of Venezuela in 1976?
Your answer should be compact. 21.82. What is the difference between the Pupil-teacher ratio(headcount basis) of Congo (Republic) in 1975 and the Pupil-teacher ratio(headcount basis) of Virgin Islands in 1976?
Provide a short and direct response. 23.16. What is the difference between the Pupil-teacher ratio(headcount basis) in Venezuela in 1975 and the Pupil-teacher ratio(headcount basis) in Virgin Islands in 1976?
Give a very brief answer. -0.19. What is the difference between the Pupil-teacher ratio(headcount basis) of Lower middle income in 1975 and the Pupil-teacher ratio(headcount basis) of Congo (Republic) in 1978?
Offer a very short reply. -21.35. What is the difference between the Pupil-teacher ratio(headcount basis) in Lower middle income in 1975 and the Pupil-teacher ratio(headcount basis) in Venezuela in 1978?
Your response must be concise. 0.32. What is the difference between the Pupil-teacher ratio(headcount basis) in Lower middle income in 1975 and the Pupil-teacher ratio(headcount basis) in Virgin Islands in 1978?
Give a very brief answer. 1.48. What is the difference between the Pupil-teacher ratio(headcount basis) of Congo (Republic) in 1975 and the Pupil-teacher ratio(headcount basis) of Venezuela in 1978?
Your answer should be very brief. 21.85. What is the difference between the Pupil-teacher ratio(headcount basis) of Congo (Republic) in 1975 and the Pupil-teacher ratio(headcount basis) of Virgin Islands in 1978?
Your answer should be very brief. 23.02. What is the difference between the Pupil-teacher ratio(headcount basis) of Venezuela in 1975 and the Pupil-teacher ratio(headcount basis) of Virgin Islands in 1978?
Your answer should be compact. -0.34. What is the difference between the Pupil-teacher ratio(headcount basis) in Lower middle income in 1975 and the Pupil-teacher ratio(headcount basis) in Congo (Republic) in 1979?
Ensure brevity in your answer.  -20.79. What is the difference between the Pupil-teacher ratio(headcount basis) in Lower middle income in 1975 and the Pupil-teacher ratio(headcount basis) in Venezuela in 1979?
Your answer should be compact. 0.05. What is the difference between the Pupil-teacher ratio(headcount basis) of Lower middle income in 1975 and the Pupil-teacher ratio(headcount basis) of Virgin Islands in 1979?
Ensure brevity in your answer.  1.53. What is the difference between the Pupil-teacher ratio(headcount basis) of Congo (Republic) in 1975 and the Pupil-teacher ratio(headcount basis) of Venezuela in 1979?
Ensure brevity in your answer.  21.58. What is the difference between the Pupil-teacher ratio(headcount basis) in Congo (Republic) in 1975 and the Pupil-teacher ratio(headcount basis) in Virgin Islands in 1979?
Give a very brief answer. 23.07. What is the difference between the Pupil-teacher ratio(headcount basis) of Venezuela in 1975 and the Pupil-teacher ratio(headcount basis) of Virgin Islands in 1979?
Provide a short and direct response. -0.29. What is the difference between the Pupil-teacher ratio(headcount basis) in Lower middle income in 1975 and the Pupil-teacher ratio(headcount basis) in Congo (Republic) in 1987?
Offer a very short reply. -14.91. What is the difference between the Pupil-teacher ratio(headcount basis) of Lower middle income in 1975 and the Pupil-teacher ratio(headcount basis) of Venezuela in 1987?
Offer a very short reply. 1.48. What is the difference between the Pupil-teacher ratio(headcount basis) of Lower middle income in 1975 and the Pupil-teacher ratio(headcount basis) of Virgin Islands in 1987?
Keep it short and to the point. 1.53. What is the difference between the Pupil-teacher ratio(headcount basis) in Congo (Republic) in 1975 and the Pupil-teacher ratio(headcount basis) in Venezuela in 1987?
Ensure brevity in your answer.  23.02. What is the difference between the Pupil-teacher ratio(headcount basis) in Congo (Republic) in 1975 and the Pupil-teacher ratio(headcount basis) in Virgin Islands in 1987?
Make the answer very short. 23.06. What is the difference between the Pupil-teacher ratio(headcount basis) in Venezuela in 1975 and the Pupil-teacher ratio(headcount basis) in Virgin Islands in 1987?
Offer a very short reply. -0.29. What is the difference between the Pupil-teacher ratio(headcount basis) in Lower middle income in 1976 and the Pupil-teacher ratio(headcount basis) in Congo (Republic) in 1978?
Offer a very short reply. -21.02. What is the difference between the Pupil-teacher ratio(headcount basis) in Lower middle income in 1976 and the Pupil-teacher ratio(headcount basis) in Venezuela in 1978?
Provide a short and direct response. 0.65. What is the difference between the Pupil-teacher ratio(headcount basis) in Lower middle income in 1976 and the Pupil-teacher ratio(headcount basis) in Virgin Islands in 1978?
Offer a terse response. 1.81. What is the difference between the Pupil-teacher ratio(headcount basis) of Congo (Republic) in 1976 and the Pupil-teacher ratio(headcount basis) of Venezuela in 1978?
Your response must be concise. 23.12. What is the difference between the Pupil-teacher ratio(headcount basis) in Congo (Republic) in 1976 and the Pupil-teacher ratio(headcount basis) in Virgin Islands in 1978?
Your answer should be very brief. 24.28. What is the difference between the Pupil-teacher ratio(headcount basis) in Venezuela in 1976 and the Pupil-teacher ratio(headcount basis) in Virgin Islands in 1978?
Your response must be concise. 1.19. What is the difference between the Pupil-teacher ratio(headcount basis) of Lower middle income in 1976 and the Pupil-teacher ratio(headcount basis) of Congo (Republic) in 1979?
Keep it short and to the point. -20.46. What is the difference between the Pupil-teacher ratio(headcount basis) of Lower middle income in 1976 and the Pupil-teacher ratio(headcount basis) of Venezuela in 1979?
Your answer should be very brief. 0.38. What is the difference between the Pupil-teacher ratio(headcount basis) in Lower middle income in 1976 and the Pupil-teacher ratio(headcount basis) in Virgin Islands in 1979?
Your answer should be very brief. 1.86. What is the difference between the Pupil-teacher ratio(headcount basis) of Congo (Republic) in 1976 and the Pupil-teacher ratio(headcount basis) of Venezuela in 1979?
Offer a very short reply. 22.85. What is the difference between the Pupil-teacher ratio(headcount basis) in Congo (Republic) in 1976 and the Pupil-teacher ratio(headcount basis) in Virgin Islands in 1979?
Your answer should be very brief. 24.33. What is the difference between the Pupil-teacher ratio(headcount basis) in Venezuela in 1976 and the Pupil-teacher ratio(headcount basis) in Virgin Islands in 1979?
Make the answer very short. 1.24. What is the difference between the Pupil-teacher ratio(headcount basis) in Lower middle income in 1976 and the Pupil-teacher ratio(headcount basis) in Congo (Republic) in 1987?
Your answer should be compact. -14.58. What is the difference between the Pupil-teacher ratio(headcount basis) of Lower middle income in 1976 and the Pupil-teacher ratio(headcount basis) of Venezuela in 1987?
Give a very brief answer. 1.81. What is the difference between the Pupil-teacher ratio(headcount basis) in Lower middle income in 1976 and the Pupil-teacher ratio(headcount basis) in Virgin Islands in 1987?
Your answer should be compact. 1.86. What is the difference between the Pupil-teacher ratio(headcount basis) of Congo (Republic) in 1976 and the Pupil-teacher ratio(headcount basis) of Venezuela in 1987?
Your answer should be compact. 24.28. What is the difference between the Pupil-teacher ratio(headcount basis) in Congo (Republic) in 1976 and the Pupil-teacher ratio(headcount basis) in Virgin Islands in 1987?
Your answer should be very brief. 24.33. What is the difference between the Pupil-teacher ratio(headcount basis) in Venezuela in 1976 and the Pupil-teacher ratio(headcount basis) in Virgin Islands in 1987?
Your answer should be very brief. 1.24. What is the difference between the Pupil-teacher ratio(headcount basis) of Lower middle income in 1978 and the Pupil-teacher ratio(headcount basis) of Congo (Republic) in 1979?
Your answer should be very brief. -20.02. What is the difference between the Pupil-teacher ratio(headcount basis) of Lower middle income in 1978 and the Pupil-teacher ratio(headcount basis) of Venezuela in 1979?
Your answer should be compact. 0.82. What is the difference between the Pupil-teacher ratio(headcount basis) in Lower middle income in 1978 and the Pupil-teacher ratio(headcount basis) in Virgin Islands in 1979?
Offer a very short reply. 2.3. What is the difference between the Pupil-teacher ratio(headcount basis) of Congo (Republic) in 1978 and the Pupil-teacher ratio(headcount basis) of Venezuela in 1979?
Your answer should be very brief. 21.39. What is the difference between the Pupil-teacher ratio(headcount basis) of Congo (Republic) in 1978 and the Pupil-teacher ratio(headcount basis) of Virgin Islands in 1979?
Keep it short and to the point. 22.88. What is the difference between the Pupil-teacher ratio(headcount basis) in Venezuela in 1978 and the Pupil-teacher ratio(headcount basis) in Virgin Islands in 1979?
Keep it short and to the point. 1.21. What is the difference between the Pupil-teacher ratio(headcount basis) in Lower middle income in 1978 and the Pupil-teacher ratio(headcount basis) in Congo (Republic) in 1987?
Provide a short and direct response. -14.14. What is the difference between the Pupil-teacher ratio(headcount basis) in Lower middle income in 1978 and the Pupil-teacher ratio(headcount basis) in Venezuela in 1987?
Provide a succinct answer. 2.25. What is the difference between the Pupil-teacher ratio(headcount basis) of Lower middle income in 1978 and the Pupil-teacher ratio(headcount basis) of Virgin Islands in 1987?
Offer a terse response. 2.3. What is the difference between the Pupil-teacher ratio(headcount basis) of Congo (Republic) in 1978 and the Pupil-teacher ratio(headcount basis) of Venezuela in 1987?
Ensure brevity in your answer.  22.83. What is the difference between the Pupil-teacher ratio(headcount basis) of Congo (Republic) in 1978 and the Pupil-teacher ratio(headcount basis) of Virgin Islands in 1987?
Provide a short and direct response. 22.88. What is the difference between the Pupil-teacher ratio(headcount basis) of Venezuela in 1978 and the Pupil-teacher ratio(headcount basis) of Virgin Islands in 1987?
Provide a succinct answer. 1.21. What is the difference between the Pupil-teacher ratio(headcount basis) in Lower middle income in 1979 and the Pupil-teacher ratio(headcount basis) in Congo (Republic) in 1987?
Offer a terse response. -13.94. What is the difference between the Pupil-teacher ratio(headcount basis) in Lower middle income in 1979 and the Pupil-teacher ratio(headcount basis) in Venezuela in 1987?
Your answer should be compact. 2.46. What is the difference between the Pupil-teacher ratio(headcount basis) of Lower middle income in 1979 and the Pupil-teacher ratio(headcount basis) of Virgin Islands in 1987?
Your answer should be compact. 2.5. What is the difference between the Pupil-teacher ratio(headcount basis) in Congo (Republic) in 1979 and the Pupil-teacher ratio(headcount basis) in Venezuela in 1987?
Offer a very short reply. 22.28. What is the difference between the Pupil-teacher ratio(headcount basis) of Congo (Republic) in 1979 and the Pupil-teacher ratio(headcount basis) of Virgin Islands in 1987?
Your response must be concise. 22.32. What is the difference between the Pupil-teacher ratio(headcount basis) of Venezuela in 1979 and the Pupil-teacher ratio(headcount basis) of Virgin Islands in 1987?
Provide a short and direct response. 1.48. What is the average Pupil-teacher ratio(headcount basis) of Lower middle income per year?
Give a very brief answer. 19.85. What is the average Pupil-teacher ratio(headcount basis) of Congo (Republic) per year?
Give a very brief answer. 39.95. What is the average Pupil-teacher ratio(headcount basis) in Venezuela per year?
Your response must be concise. 18.68. What is the average Pupil-teacher ratio(headcount basis) of Virgin Islands per year?
Offer a very short reply. 17.49. In the year 1972, what is the difference between the Pupil-teacher ratio(headcount basis) of Lower middle income and Pupil-teacher ratio(headcount basis) of Congo (Republic)?
Give a very brief answer. -16.33. In the year 1972, what is the difference between the Pupil-teacher ratio(headcount basis) of Lower middle income and Pupil-teacher ratio(headcount basis) of Venezuela?
Make the answer very short. 0.88. In the year 1972, what is the difference between the Pupil-teacher ratio(headcount basis) of Lower middle income and Pupil-teacher ratio(headcount basis) of Virgin Islands?
Offer a terse response. 4.41. In the year 1972, what is the difference between the Pupil-teacher ratio(headcount basis) in Congo (Republic) and Pupil-teacher ratio(headcount basis) in Venezuela?
Provide a short and direct response. 17.21. In the year 1972, what is the difference between the Pupil-teacher ratio(headcount basis) in Congo (Republic) and Pupil-teacher ratio(headcount basis) in Virgin Islands?
Your answer should be very brief. 20.74. In the year 1972, what is the difference between the Pupil-teacher ratio(headcount basis) in Venezuela and Pupil-teacher ratio(headcount basis) in Virgin Islands?
Offer a very short reply. 3.53. In the year 1973, what is the difference between the Pupil-teacher ratio(headcount basis) of Lower middle income and Pupil-teacher ratio(headcount basis) of Congo (Republic)?
Ensure brevity in your answer.  -23.12. In the year 1973, what is the difference between the Pupil-teacher ratio(headcount basis) in Lower middle income and Pupil-teacher ratio(headcount basis) in Venezuela?
Your answer should be very brief. 0.23. In the year 1973, what is the difference between the Pupil-teacher ratio(headcount basis) of Lower middle income and Pupil-teacher ratio(headcount basis) of Virgin Islands?
Offer a terse response. 1.24. In the year 1973, what is the difference between the Pupil-teacher ratio(headcount basis) of Congo (Republic) and Pupil-teacher ratio(headcount basis) of Venezuela?
Offer a very short reply. 23.35. In the year 1973, what is the difference between the Pupil-teacher ratio(headcount basis) in Congo (Republic) and Pupil-teacher ratio(headcount basis) in Virgin Islands?
Your response must be concise. 24.36. In the year 1973, what is the difference between the Pupil-teacher ratio(headcount basis) in Venezuela and Pupil-teacher ratio(headcount basis) in Virgin Islands?
Your answer should be very brief. 1.02. In the year 1974, what is the difference between the Pupil-teacher ratio(headcount basis) of Lower middle income and Pupil-teacher ratio(headcount basis) of Congo (Republic)?
Make the answer very short. -23.87. In the year 1974, what is the difference between the Pupil-teacher ratio(headcount basis) in Lower middle income and Pupil-teacher ratio(headcount basis) in Venezuela?
Provide a short and direct response. 0.37. In the year 1974, what is the difference between the Pupil-teacher ratio(headcount basis) of Lower middle income and Pupil-teacher ratio(headcount basis) of Virgin Islands?
Offer a terse response. 1.47. In the year 1974, what is the difference between the Pupil-teacher ratio(headcount basis) in Congo (Republic) and Pupil-teacher ratio(headcount basis) in Venezuela?
Give a very brief answer. 24.24. In the year 1974, what is the difference between the Pupil-teacher ratio(headcount basis) of Congo (Republic) and Pupil-teacher ratio(headcount basis) of Virgin Islands?
Provide a succinct answer. 25.35. In the year 1974, what is the difference between the Pupil-teacher ratio(headcount basis) in Venezuela and Pupil-teacher ratio(headcount basis) in Virgin Islands?
Your answer should be compact. 1.11. In the year 1975, what is the difference between the Pupil-teacher ratio(headcount basis) of Lower middle income and Pupil-teacher ratio(headcount basis) of Congo (Republic)?
Keep it short and to the point. -21.53. In the year 1975, what is the difference between the Pupil-teacher ratio(headcount basis) in Lower middle income and Pupil-teacher ratio(headcount basis) in Venezuela?
Give a very brief answer. 1.82. In the year 1975, what is the difference between the Pupil-teacher ratio(headcount basis) in Lower middle income and Pupil-teacher ratio(headcount basis) in Virgin Islands?
Your answer should be very brief. 1.69. In the year 1975, what is the difference between the Pupil-teacher ratio(headcount basis) of Congo (Republic) and Pupil-teacher ratio(headcount basis) of Venezuela?
Keep it short and to the point. 23.35. In the year 1975, what is the difference between the Pupil-teacher ratio(headcount basis) in Congo (Republic) and Pupil-teacher ratio(headcount basis) in Virgin Islands?
Keep it short and to the point. 23.23. In the year 1975, what is the difference between the Pupil-teacher ratio(headcount basis) in Venezuela and Pupil-teacher ratio(headcount basis) in Virgin Islands?
Provide a short and direct response. -0.13. In the year 1976, what is the difference between the Pupil-teacher ratio(headcount basis) in Lower middle income and Pupil-teacher ratio(headcount basis) in Congo (Republic)?
Provide a short and direct response. -22.47. In the year 1976, what is the difference between the Pupil-teacher ratio(headcount basis) in Lower middle income and Pupil-teacher ratio(headcount basis) in Venezuela?
Your answer should be compact. 0.62. In the year 1976, what is the difference between the Pupil-teacher ratio(headcount basis) of Lower middle income and Pupil-teacher ratio(headcount basis) of Virgin Islands?
Your answer should be compact. 1.96. In the year 1976, what is the difference between the Pupil-teacher ratio(headcount basis) of Congo (Republic) and Pupil-teacher ratio(headcount basis) of Venezuela?
Make the answer very short. 23.09. In the year 1976, what is the difference between the Pupil-teacher ratio(headcount basis) of Congo (Republic) and Pupil-teacher ratio(headcount basis) of Virgin Islands?
Keep it short and to the point. 24.43. In the year 1976, what is the difference between the Pupil-teacher ratio(headcount basis) of Venezuela and Pupil-teacher ratio(headcount basis) of Virgin Islands?
Your answer should be compact. 1.34. In the year 1978, what is the difference between the Pupil-teacher ratio(headcount basis) of Lower middle income and Pupil-teacher ratio(headcount basis) of Congo (Republic)?
Give a very brief answer. -20.58. In the year 1978, what is the difference between the Pupil-teacher ratio(headcount basis) in Lower middle income and Pupil-teacher ratio(headcount basis) in Venezuela?
Your response must be concise. 1.09. In the year 1978, what is the difference between the Pupil-teacher ratio(headcount basis) in Lower middle income and Pupil-teacher ratio(headcount basis) in Virgin Islands?
Ensure brevity in your answer.  2.25. In the year 1978, what is the difference between the Pupil-teacher ratio(headcount basis) in Congo (Republic) and Pupil-teacher ratio(headcount basis) in Venezuela?
Make the answer very short. 21.66. In the year 1978, what is the difference between the Pupil-teacher ratio(headcount basis) of Congo (Republic) and Pupil-teacher ratio(headcount basis) of Virgin Islands?
Ensure brevity in your answer.  22.83. In the year 1978, what is the difference between the Pupil-teacher ratio(headcount basis) in Venezuela and Pupil-teacher ratio(headcount basis) in Virgin Islands?
Provide a succinct answer. 1.16. In the year 1979, what is the difference between the Pupil-teacher ratio(headcount basis) in Lower middle income and Pupil-teacher ratio(headcount basis) in Congo (Republic)?
Ensure brevity in your answer.  -19.82. In the year 1979, what is the difference between the Pupil-teacher ratio(headcount basis) in Lower middle income and Pupil-teacher ratio(headcount basis) in Virgin Islands?
Offer a very short reply. 2.51. In the year 1979, what is the difference between the Pupil-teacher ratio(headcount basis) in Congo (Republic) and Pupil-teacher ratio(headcount basis) in Venezuela?
Keep it short and to the point. 20.84. In the year 1979, what is the difference between the Pupil-teacher ratio(headcount basis) in Congo (Republic) and Pupil-teacher ratio(headcount basis) in Virgin Islands?
Offer a terse response. 22.33. In the year 1979, what is the difference between the Pupil-teacher ratio(headcount basis) of Venezuela and Pupil-teacher ratio(headcount basis) of Virgin Islands?
Your response must be concise. 1.49. In the year 1987, what is the difference between the Pupil-teacher ratio(headcount basis) of Lower middle income and Pupil-teacher ratio(headcount basis) of Congo (Republic)?
Provide a succinct answer. -13.1. In the year 1987, what is the difference between the Pupil-teacher ratio(headcount basis) of Lower middle income and Pupil-teacher ratio(headcount basis) of Venezuela?
Offer a very short reply. 3.3. In the year 1987, what is the difference between the Pupil-teacher ratio(headcount basis) of Lower middle income and Pupil-teacher ratio(headcount basis) of Virgin Islands?
Make the answer very short. 3.35. In the year 1987, what is the difference between the Pupil-teacher ratio(headcount basis) in Congo (Republic) and Pupil-teacher ratio(headcount basis) in Venezuela?
Provide a short and direct response. 16.4. In the year 1987, what is the difference between the Pupil-teacher ratio(headcount basis) of Congo (Republic) and Pupil-teacher ratio(headcount basis) of Virgin Islands?
Provide a short and direct response. 16.44. In the year 1987, what is the difference between the Pupil-teacher ratio(headcount basis) in Venezuela and Pupil-teacher ratio(headcount basis) in Virgin Islands?
Provide a short and direct response. 0.05. What is the ratio of the Pupil-teacher ratio(headcount basis) of Congo (Republic) in 1972 to that in 1973?
Offer a terse response. 0.84. What is the ratio of the Pupil-teacher ratio(headcount basis) of Venezuela in 1972 to that in 1973?
Your answer should be compact. 0.96. What is the ratio of the Pupil-teacher ratio(headcount basis) in Virgin Islands in 1972 to that in 1973?
Ensure brevity in your answer.  0.82. What is the ratio of the Pupil-teacher ratio(headcount basis) in Lower middle income in 1972 to that in 1974?
Keep it short and to the point. 0.99. What is the ratio of the Pupil-teacher ratio(headcount basis) in Congo (Republic) in 1972 to that in 1974?
Give a very brief answer. 0.82. What is the ratio of the Pupil-teacher ratio(headcount basis) of Venezuela in 1972 to that in 1974?
Your answer should be very brief. 0.96. What is the ratio of the Pupil-teacher ratio(headcount basis) in Virgin Islands in 1972 to that in 1974?
Provide a succinct answer. 0.82. What is the ratio of the Pupil-teacher ratio(headcount basis) of Lower middle income in 1972 to that in 1975?
Provide a succinct answer. 0.97. What is the ratio of the Pupil-teacher ratio(headcount basis) of Congo (Republic) in 1972 to that in 1975?
Provide a short and direct response. 0.86. What is the ratio of the Pupil-teacher ratio(headcount basis) of Venezuela in 1972 to that in 1975?
Provide a short and direct response. 1.02. What is the ratio of the Pupil-teacher ratio(headcount basis) of Virgin Islands in 1972 to that in 1975?
Offer a terse response. 0.82. What is the ratio of the Pupil-teacher ratio(headcount basis) in Lower middle income in 1972 to that in 1976?
Provide a succinct answer. 0.96. What is the ratio of the Pupil-teacher ratio(headcount basis) in Congo (Republic) in 1972 to that in 1976?
Give a very brief answer. 0.83. What is the ratio of the Pupil-teacher ratio(headcount basis) of Venezuela in 1972 to that in 1976?
Give a very brief answer. 0.94. What is the ratio of the Pupil-teacher ratio(headcount basis) in Virgin Islands in 1972 to that in 1976?
Keep it short and to the point. 0.81. What is the ratio of the Pupil-teacher ratio(headcount basis) of Lower middle income in 1972 to that in 1978?
Your answer should be compact. 0.94. What is the ratio of the Pupil-teacher ratio(headcount basis) in Congo (Republic) in 1972 to that in 1978?
Provide a succinct answer. 0.86. What is the ratio of the Pupil-teacher ratio(headcount basis) in Venezuela in 1972 to that in 1978?
Provide a succinct answer. 0.94. What is the ratio of the Pupil-teacher ratio(headcount basis) of Virgin Islands in 1972 to that in 1978?
Give a very brief answer. 0.81. What is the ratio of the Pupil-teacher ratio(headcount basis) of Lower middle income in 1972 to that in 1979?
Provide a succinct answer. 0.93. What is the ratio of the Pupil-teacher ratio(headcount basis) of Congo (Republic) in 1972 to that in 1979?
Provide a succinct answer. 0.88. What is the ratio of the Pupil-teacher ratio(headcount basis) of Venezuela in 1972 to that in 1979?
Your answer should be very brief. 0.93. What is the ratio of the Pupil-teacher ratio(headcount basis) in Virgin Islands in 1972 to that in 1979?
Provide a short and direct response. 0.81. What is the ratio of the Pupil-teacher ratio(headcount basis) in Lower middle income in 1972 to that in 1987?
Make the answer very short. 0.89. What is the ratio of the Pupil-teacher ratio(headcount basis) of Congo (Republic) in 1972 to that in 1987?
Make the answer very short. 1.03. What is the ratio of the Pupil-teacher ratio(headcount basis) in Virgin Islands in 1972 to that in 1987?
Provide a short and direct response. 0.81. What is the ratio of the Pupil-teacher ratio(headcount basis) in Lower middle income in 1973 to that in 1974?
Your answer should be compact. 0.99. What is the ratio of the Pupil-teacher ratio(headcount basis) in Congo (Republic) in 1973 to that in 1974?
Offer a terse response. 0.98. What is the ratio of the Pupil-teacher ratio(headcount basis) in Virgin Islands in 1973 to that in 1974?
Provide a short and direct response. 1. What is the ratio of the Pupil-teacher ratio(headcount basis) of Lower middle income in 1973 to that in 1975?
Keep it short and to the point. 0.98. What is the ratio of the Pupil-teacher ratio(headcount basis) of Congo (Republic) in 1973 to that in 1975?
Offer a very short reply. 1.03. What is the ratio of the Pupil-teacher ratio(headcount basis) in Venezuela in 1973 to that in 1975?
Provide a succinct answer. 1.06. What is the ratio of the Pupil-teacher ratio(headcount basis) of Lower middle income in 1973 to that in 1976?
Your answer should be compact. 0.96. What is the ratio of the Pupil-teacher ratio(headcount basis) in Congo (Republic) in 1973 to that in 1976?
Make the answer very short. 1. What is the ratio of the Pupil-teacher ratio(headcount basis) of Venezuela in 1973 to that in 1976?
Give a very brief answer. 0.98. What is the ratio of the Pupil-teacher ratio(headcount basis) in Virgin Islands in 1973 to that in 1976?
Your answer should be compact. 0.99. What is the ratio of the Pupil-teacher ratio(headcount basis) in Lower middle income in 1973 to that in 1978?
Give a very brief answer. 0.94. What is the ratio of the Pupil-teacher ratio(headcount basis) in Congo (Republic) in 1973 to that in 1978?
Your response must be concise. 1.03. What is the ratio of the Pupil-teacher ratio(headcount basis) in Venezuela in 1973 to that in 1978?
Offer a very short reply. 0.98. What is the ratio of the Pupil-teacher ratio(headcount basis) in Lower middle income in 1973 to that in 1979?
Offer a very short reply. 0.93. What is the ratio of the Pupil-teacher ratio(headcount basis) of Congo (Republic) in 1973 to that in 1979?
Offer a very short reply. 1.05. What is the ratio of the Pupil-teacher ratio(headcount basis) in Venezuela in 1973 to that in 1979?
Provide a succinct answer. 0.97. What is the ratio of the Pupil-teacher ratio(headcount basis) in Virgin Islands in 1973 to that in 1979?
Give a very brief answer. 0.99. What is the ratio of the Pupil-teacher ratio(headcount basis) of Lower middle income in 1973 to that in 1987?
Provide a short and direct response. 0.89. What is the ratio of the Pupil-teacher ratio(headcount basis) in Congo (Republic) in 1973 to that in 1987?
Provide a short and direct response. 1.22. What is the ratio of the Pupil-teacher ratio(headcount basis) in Venezuela in 1973 to that in 1987?
Your response must be concise. 1.04. What is the ratio of the Pupil-teacher ratio(headcount basis) in Lower middle income in 1974 to that in 1975?
Your answer should be compact. 0.99. What is the ratio of the Pupil-teacher ratio(headcount basis) in Congo (Republic) in 1974 to that in 1975?
Ensure brevity in your answer.  1.05. What is the ratio of the Pupil-teacher ratio(headcount basis) of Venezuela in 1974 to that in 1975?
Your answer should be very brief. 1.07. What is the ratio of the Pupil-teacher ratio(headcount basis) in Virgin Islands in 1974 to that in 1975?
Give a very brief answer. 1. What is the ratio of the Pupil-teacher ratio(headcount basis) in Lower middle income in 1974 to that in 1976?
Your answer should be compact. 0.97. What is the ratio of the Pupil-teacher ratio(headcount basis) of Congo (Republic) in 1974 to that in 1976?
Your response must be concise. 1.02. What is the ratio of the Pupil-teacher ratio(headcount basis) of Venezuela in 1974 to that in 1976?
Your response must be concise. 0.98. What is the ratio of the Pupil-teacher ratio(headcount basis) in Virgin Islands in 1974 to that in 1976?
Provide a short and direct response. 0.99. What is the ratio of the Pupil-teacher ratio(headcount basis) in Lower middle income in 1974 to that in 1978?
Keep it short and to the point. 0.95. What is the ratio of the Pupil-teacher ratio(headcount basis) of Congo (Republic) in 1974 to that in 1978?
Give a very brief answer. 1.06. What is the ratio of the Pupil-teacher ratio(headcount basis) in Venezuela in 1974 to that in 1978?
Ensure brevity in your answer.  0.98. What is the ratio of the Pupil-teacher ratio(headcount basis) in Virgin Islands in 1974 to that in 1978?
Your answer should be compact. 0.99. What is the ratio of the Pupil-teacher ratio(headcount basis) of Lower middle income in 1974 to that in 1979?
Your response must be concise. 0.94. What is the ratio of the Pupil-teacher ratio(headcount basis) of Congo (Republic) in 1974 to that in 1979?
Your response must be concise. 1.07. What is the ratio of the Pupil-teacher ratio(headcount basis) of Venezuela in 1974 to that in 1979?
Give a very brief answer. 0.97. What is the ratio of the Pupil-teacher ratio(headcount basis) in Virgin Islands in 1974 to that in 1979?
Your answer should be very brief. 0.99. What is the ratio of the Pupil-teacher ratio(headcount basis) of Lower middle income in 1974 to that in 1987?
Ensure brevity in your answer.  0.9. What is the ratio of the Pupil-teacher ratio(headcount basis) of Congo (Republic) in 1974 to that in 1987?
Make the answer very short. 1.25. What is the ratio of the Pupil-teacher ratio(headcount basis) of Venezuela in 1974 to that in 1987?
Ensure brevity in your answer.  1.05. What is the ratio of the Pupil-teacher ratio(headcount basis) in Lower middle income in 1975 to that in 1976?
Your answer should be very brief. 0.98. What is the ratio of the Pupil-teacher ratio(headcount basis) of Congo (Republic) in 1975 to that in 1976?
Give a very brief answer. 0.97. What is the ratio of the Pupil-teacher ratio(headcount basis) in Venezuela in 1975 to that in 1976?
Give a very brief answer. 0.92. What is the ratio of the Pupil-teacher ratio(headcount basis) of Lower middle income in 1975 to that in 1978?
Offer a terse response. 0.96. What is the ratio of the Pupil-teacher ratio(headcount basis) of Congo (Republic) in 1975 to that in 1978?
Your response must be concise. 1. What is the ratio of the Pupil-teacher ratio(headcount basis) of Venezuela in 1975 to that in 1978?
Your answer should be very brief. 0.92. What is the ratio of the Pupil-teacher ratio(headcount basis) in Virgin Islands in 1975 to that in 1978?
Provide a short and direct response. 0.99. What is the ratio of the Pupil-teacher ratio(headcount basis) of Lower middle income in 1975 to that in 1979?
Provide a succinct answer. 0.95. What is the ratio of the Pupil-teacher ratio(headcount basis) in Congo (Republic) in 1975 to that in 1979?
Keep it short and to the point. 1.02. What is the ratio of the Pupil-teacher ratio(headcount basis) in Venezuela in 1975 to that in 1979?
Provide a short and direct response. 0.91. What is the ratio of the Pupil-teacher ratio(headcount basis) of Lower middle income in 1975 to that in 1987?
Provide a short and direct response. 0.91. What is the ratio of the Pupil-teacher ratio(headcount basis) of Congo (Republic) in 1975 to that in 1987?
Your answer should be compact. 1.19. What is the ratio of the Pupil-teacher ratio(headcount basis) of Venezuela in 1975 to that in 1987?
Offer a very short reply. 0.98. What is the ratio of the Pupil-teacher ratio(headcount basis) in Lower middle income in 1976 to that in 1978?
Keep it short and to the point. 0.98. What is the ratio of the Pupil-teacher ratio(headcount basis) of Congo (Republic) in 1976 to that in 1978?
Offer a very short reply. 1.04. What is the ratio of the Pupil-teacher ratio(headcount basis) in Lower middle income in 1976 to that in 1979?
Your answer should be compact. 0.97. What is the ratio of the Pupil-teacher ratio(headcount basis) in Congo (Republic) in 1976 to that in 1979?
Provide a short and direct response. 1.05. What is the ratio of the Pupil-teacher ratio(headcount basis) in Venezuela in 1976 to that in 1979?
Ensure brevity in your answer.  0.99. What is the ratio of the Pupil-teacher ratio(headcount basis) of Virgin Islands in 1976 to that in 1979?
Your response must be concise. 0.99. What is the ratio of the Pupil-teacher ratio(headcount basis) in Lower middle income in 1976 to that in 1987?
Provide a succinct answer. 0.93. What is the ratio of the Pupil-teacher ratio(headcount basis) in Congo (Republic) in 1976 to that in 1987?
Offer a terse response. 1.23. What is the ratio of the Pupil-teacher ratio(headcount basis) in Venezuela in 1976 to that in 1987?
Provide a short and direct response. 1.07. What is the ratio of the Pupil-teacher ratio(headcount basis) of Virgin Islands in 1976 to that in 1987?
Keep it short and to the point. 0.99. What is the ratio of the Pupil-teacher ratio(headcount basis) of Congo (Republic) in 1978 to that in 1979?
Give a very brief answer. 1.01. What is the ratio of the Pupil-teacher ratio(headcount basis) of Lower middle income in 1978 to that in 1987?
Offer a terse response. 0.95. What is the ratio of the Pupil-teacher ratio(headcount basis) in Congo (Republic) in 1978 to that in 1987?
Keep it short and to the point. 1.19. What is the ratio of the Pupil-teacher ratio(headcount basis) of Venezuela in 1978 to that in 1987?
Your response must be concise. 1.06. What is the ratio of the Pupil-teacher ratio(headcount basis) in Virgin Islands in 1978 to that in 1987?
Give a very brief answer. 1. What is the ratio of the Pupil-teacher ratio(headcount basis) of Lower middle income in 1979 to that in 1987?
Make the answer very short. 0.96. What is the ratio of the Pupil-teacher ratio(headcount basis) of Congo (Republic) in 1979 to that in 1987?
Your answer should be compact. 1.17. What is the ratio of the Pupil-teacher ratio(headcount basis) in Venezuela in 1979 to that in 1987?
Ensure brevity in your answer.  1.08. What is the ratio of the Pupil-teacher ratio(headcount basis) of Virgin Islands in 1979 to that in 1987?
Provide a succinct answer. 1. What is the difference between the highest and the second highest Pupil-teacher ratio(headcount basis) of Lower middle income?
Make the answer very short. 0.84. What is the difference between the highest and the second highest Pupil-teacher ratio(headcount basis) in Congo (Republic)?
Keep it short and to the point. 0.82. What is the difference between the highest and the second highest Pupil-teacher ratio(headcount basis) of Venezuela?
Provide a short and direct response. 0.24. What is the difference between the highest and the second highest Pupil-teacher ratio(headcount basis) in Virgin Islands?
Offer a terse response. 0.05. What is the difference between the highest and the lowest Pupil-teacher ratio(headcount basis) of Lower middle income?
Your answer should be compact. 2.34. What is the difference between the highest and the lowest Pupil-teacher ratio(headcount basis) of Congo (Republic)?
Your response must be concise. 8.71. What is the difference between the highest and the lowest Pupil-teacher ratio(headcount basis) of Venezuela?
Your answer should be compact. 1.77. What is the difference between the highest and the lowest Pupil-teacher ratio(headcount basis) of Virgin Islands?
Provide a succinct answer. 3.45. 